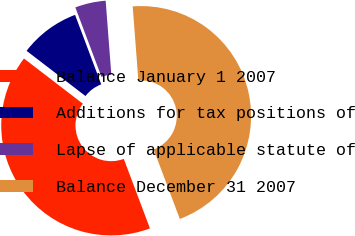Convert chart to OTSL. <chart><loc_0><loc_0><loc_500><loc_500><pie_chart><fcel>Balance January 1 2007<fcel>Additions for tax positions of<fcel>Lapse of applicable statute of<fcel>Balance December 31 2007<nl><fcel>41.15%<fcel>8.85%<fcel>4.51%<fcel>45.49%<nl></chart> 